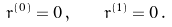<formula> <loc_0><loc_0><loc_500><loc_500>r ^ { ( 0 ) } = 0 \, , \quad r ^ { ( 1 ) } = 0 \, .</formula> 